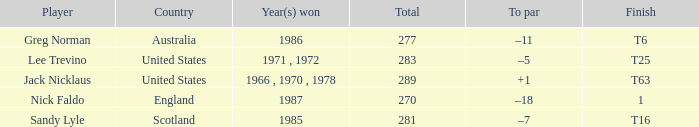What player has 1 as the place? Nick Faldo. 